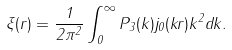<formula> <loc_0><loc_0><loc_500><loc_500>\xi ( r ) = \frac { 1 } { 2 \pi ^ { 2 } } \int _ { 0 } ^ { \infty } P _ { 3 } ( k ) j _ { 0 } ( k r ) k ^ { 2 } d k .</formula> 